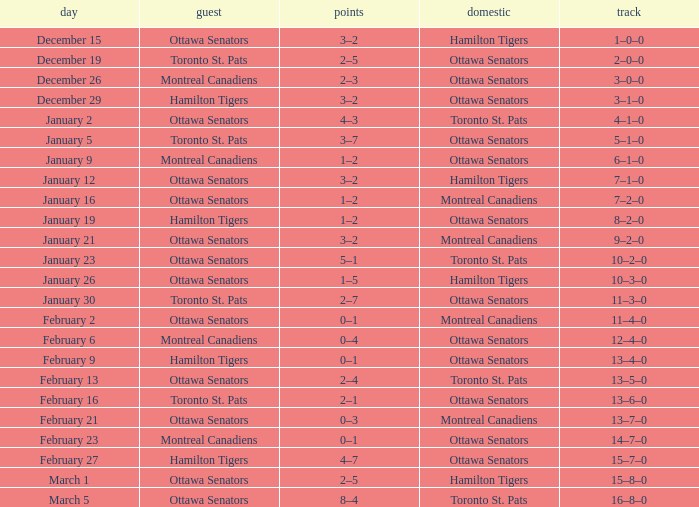What was the score on January 12? 3–2. 